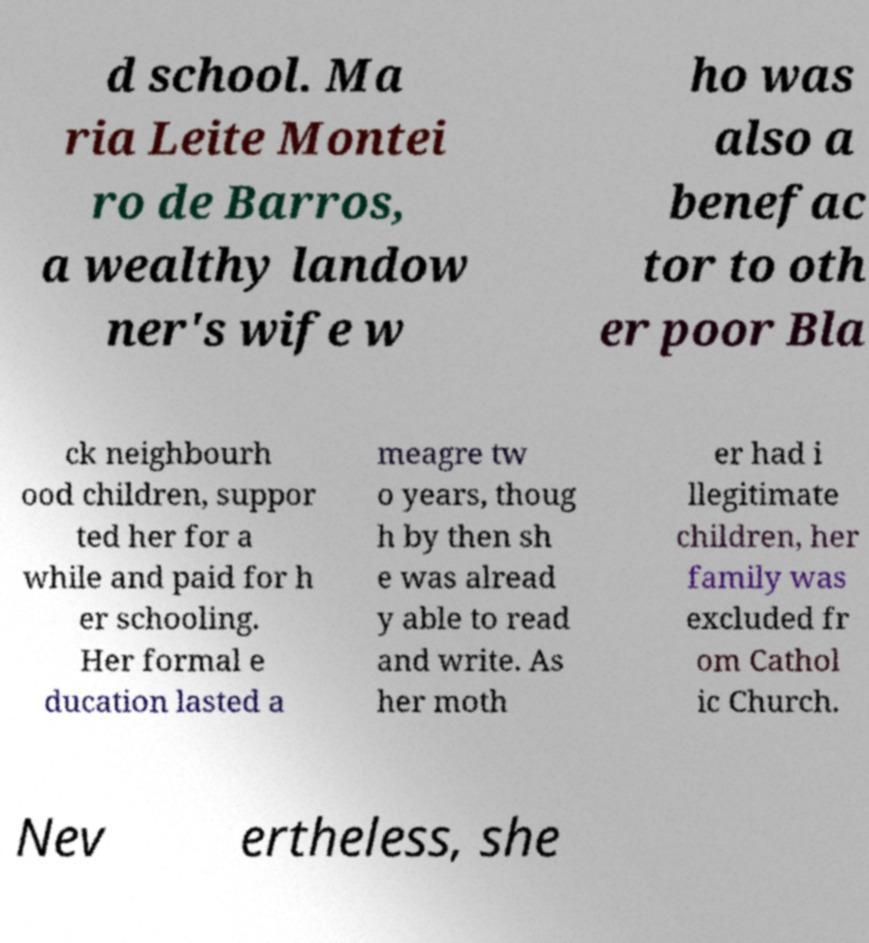Can you accurately transcribe the text from the provided image for me? d school. Ma ria Leite Montei ro de Barros, a wealthy landow ner's wife w ho was also a benefac tor to oth er poor Bla ck neighbourh ood children, suppor ted her for a while and paid for h er schooling. Her formal e ducation lasted a meagre tw o years, thoug h by then sh e was alread y able to read and write. As her moth er had i llegitimate children, her family was excluded fr om Cathol ic Church. Nev ertheless, she 